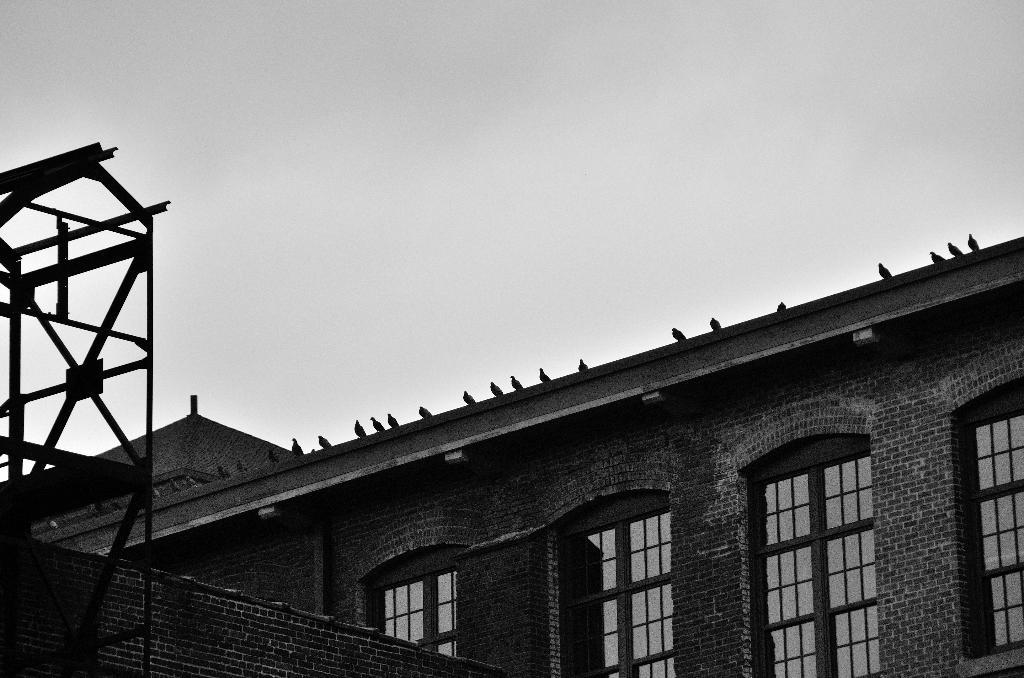What is the color scheme of the image? The image is black and white. What can be seen on the building in the image? There are birds on a building in the image. What object is present in the image that might be used for displaying or supporting something? There is a stand in the image. What is visible at the top of the image? The sky is visible at the top of the image. Can you describe the squirrel climbing up the stem of the plant in the image? There is no squirrel or plant present in the image; it features birds on a building and a stand. What is the condition of the knee of the person in the image? There is no person present in the image, so it is not possible to determine the condition of their knee. 